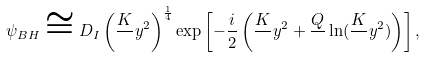Convert formula to latex. <formula><loc_0><loc_0><loc_500><loc_500>\psi _ { B H } \cong D _ { I } \left ( \frac { K } { } y ^ { 2 } \right ) ^ { \frac { 1 } { 4 } } \exp \left [ - \frac { i } { 2 } \left ( \frac { K } { } y ^ { 2 } + \frac { Q } { } \ln ( \frac { K } { } y ^ { 2 } ) \right ) \right ] ,</formula> 